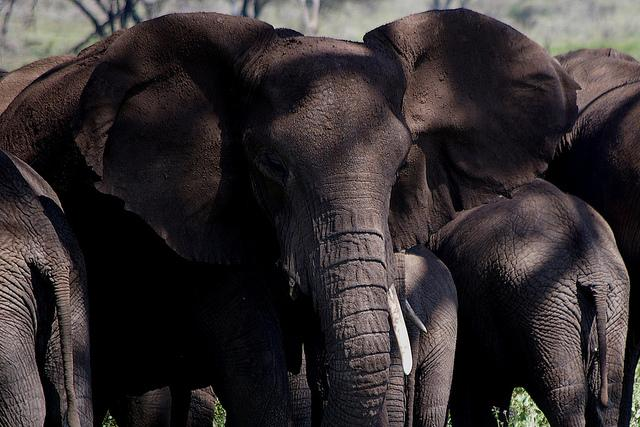What type of elephant is in the image?

Choices:
A) stuffed
B) adult
C) baby
D) dead adult 